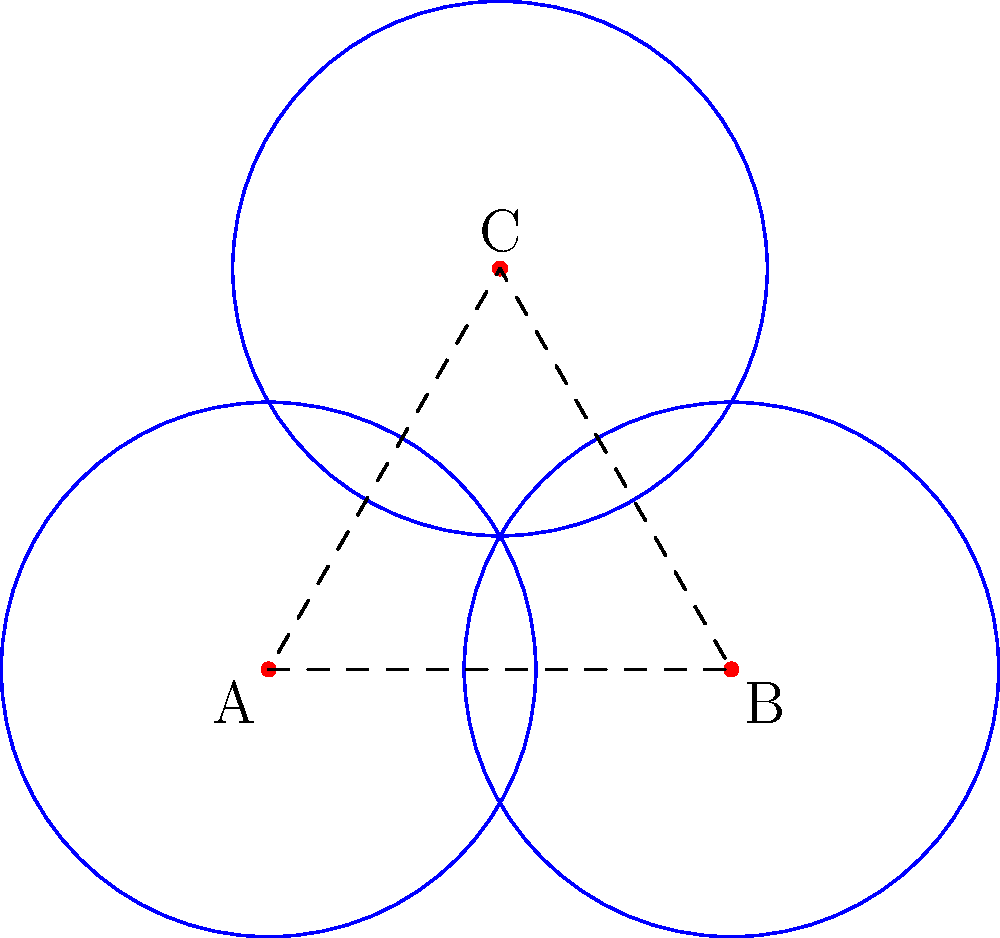Given an array of three radio telescopes arranged in an equilateral triangle formation as shown, what is the optimal radius $r$ for each telescope's coverage area to ensure maximum efficiency without overlap, expressed in terms of the side length $a$ of the triangle? To solve this problem, we'll follow these steps:

1. Recognize that the centers of the circles form an equilateral triangle.
2. Identify that the optimal radius is when the circles just touch each other.
3. Use the properties of an equilateral triangle to find the relationship between the side length and the radius.

Step 1: The centers of the telescopes form an equilateral triangle with side length $a$.

Step 2: For maximum efficiency without overlap, the circles should just touch each other. This means the distance between the centers of any two circles is equal to the sum of their radii.

Step 3: In an equilateral triangle:
- The distance between any two centers is $a$.
- The optimal radius $r$ is half of this distance.

Therefore, $r = \frac{a}{2}$

To express $r$ in terms of $a$:
$$r = \frac{a}{2}$$

This ensures that the coverage areas of the telescopes just touch each other, maximizing coverage without overlap.
Answer: $r = \frac{a}{2}$ 